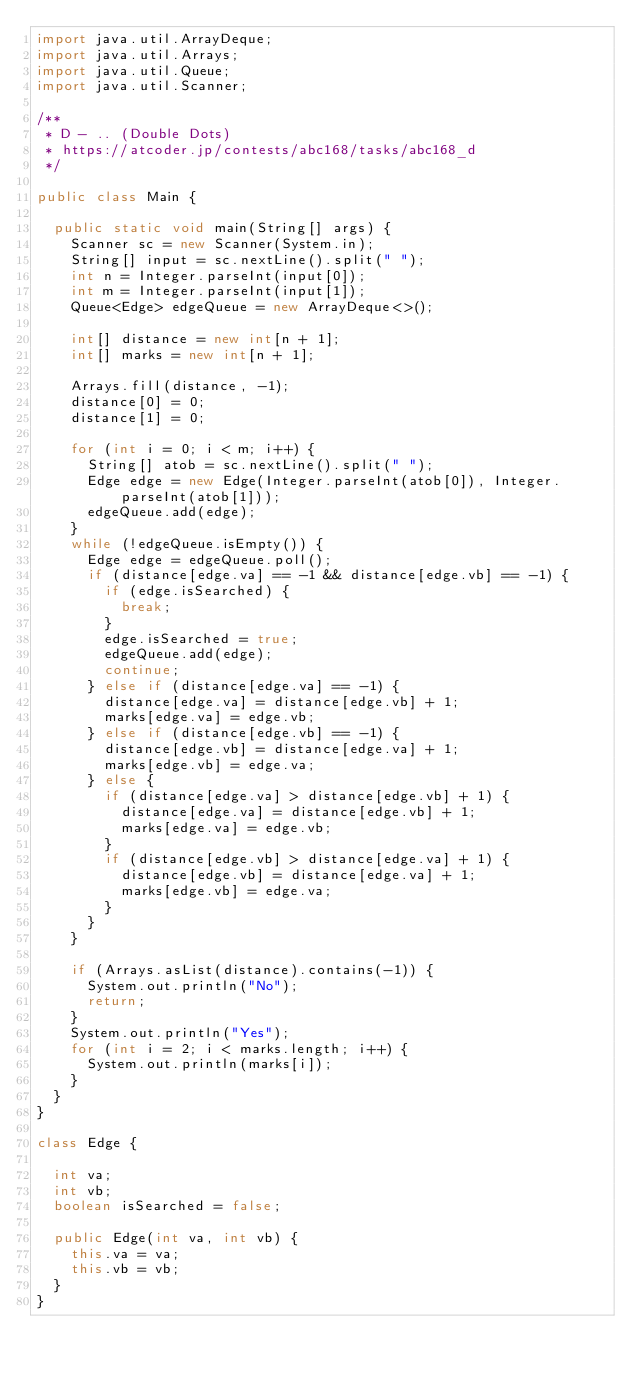Convert code to text. <code><loc_0><loc_0><loc_500><loc_500><_Java_>import java.util.ArrayDeque;
import java.util.Arrays;
import java.util.Queue;
import java.util.Scanner;

/**
 * D - .. (Double Dots)
 * https://atcoder.jp/contests/abc168/tasks/abc168_d
 */

public class Main {

  public static void main(String[] args) {
    Scanner sc = new Scanner(System.in);
    String[] input = sc.nextLine().split(" ");
    int n = Integer.parseInt(input[0]);
    int m = Integer.parseInt(input[1]);
    Queue<Edge> edgeQueue = new ArrayDeque<>();

    int[] distance = new int[n + 1];
    int[] marks = new int[n + 1];

    Arrays.fill(distance, -1);
    distance[0] = 0;
    distance[1] = 0;

    for (int i = 0; i < m; i++) {
      String[] atob = sc.nextLine().split(" ");
      Edge edge = new Edge(Integer.parseInt(atob[0]), Integer.parseInt(atob[1]));
      edgeQueue.add(edge);
    }
    while (!edgeQueue.isEmpty()) {
      Edge edge = edgeQueue.poll();
      if (distance[edge.va] == -1 && distance[edge.vb] == -1) {
        if (edge.isSearched) {
          break;
        }
        edge.isSearched = true;
        edgeQueue.add(edge);
        continue;
      } else if (distance[edge.va] == -1) {
        distance[edge.va] = distance[edge.vb] + 1;
        marks[edge.va] = edge.vb;
      } else if (distance[edge.vb] == -1) {
        distance[edge.vb] = distance[edge.va] + 1;
        marks[edge.vb] = edge.va;
      } else {
        if (distance[edge.va] > distance[edge.vb] + 1) {
          distance[edge.va] = distance[edge.vb] + 1;
          marks[edge.va] = edge.vb;
        }
        if (distance[edge.vb] > distance[edge.va] + 1) {
          distance[edge.vb] = distance[edge.va] + 1;
          marks[edge.vb] = edge.va;
        }
      }
    }

    if (Arrays.asList(distance).contains(-1)) {
      System.out.println("No");
      return;
    }
    System.out.println("Yes");
    for (int i = 2; i < marks.length; i++) {
      System.out.println(marks[i]);
    }
  }
}

class Edge {

  int va;
  int vb;
  boolean isSearched = false;

  public Edge(int va, int vb) {
    this.va = va;
    this.vb = vb;
  }
}</code> 